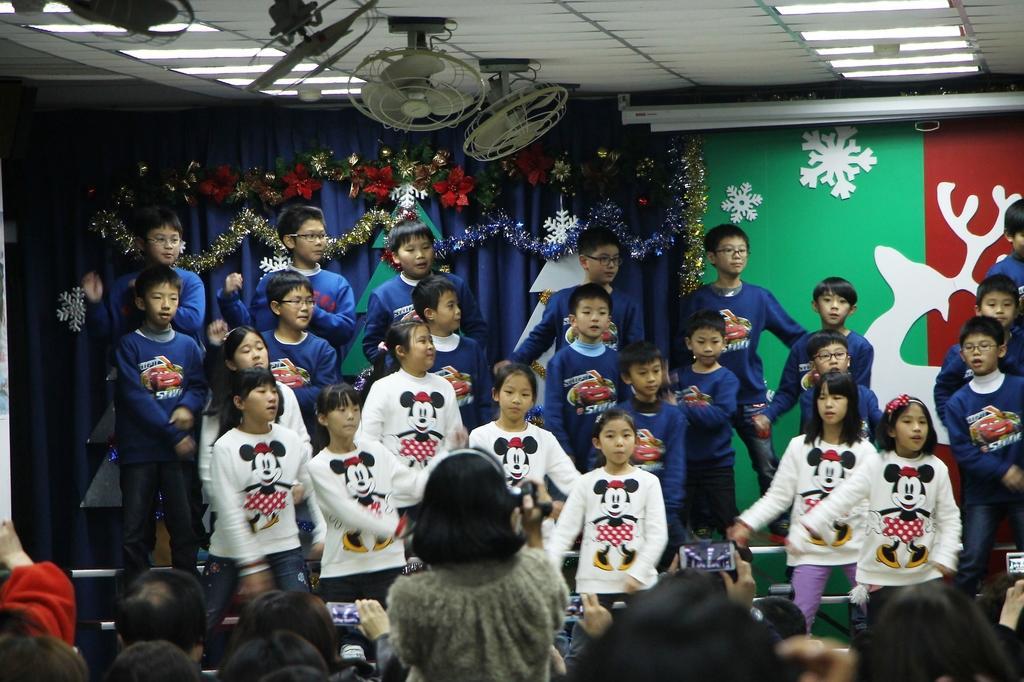Could you give a brief overview of what you see in this image? As we can see in the image there are group of people, fans, lights, decorative items and blue color curtains. There is a wall and there are mobile phones. 